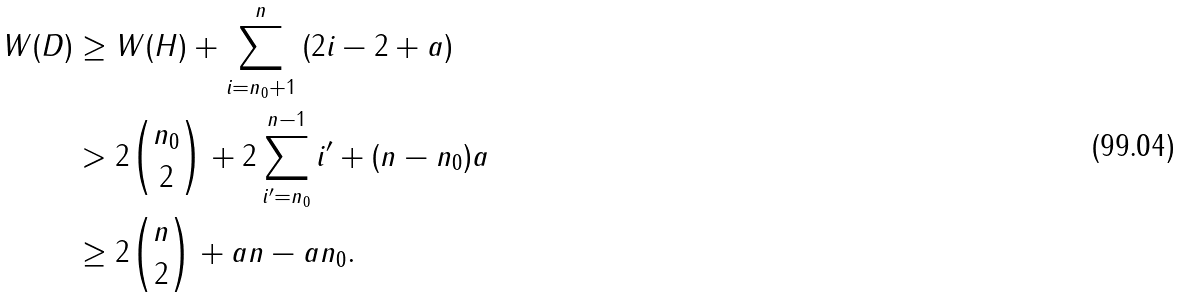Convert formula to latex. <formula><loc_0><loc_0><loc_500><loc_500>W ( D ) & \geq W ( H ) + \sum _ { i = n _ { 0 } + 1 } ^ { n } \left ( 2 i - 2 + a \right ) \\ & > 2 \binom { n _ { 0 } } { 2 } + 2 \sum _ { i ^ { \prime } = n _ { 0 } } ^ { n - 1 } i ^ { \prime } + ( n - n _ { 0 } ) a \\ & \geq 2 \binom { n } { 2 } + a n - a n _ { 0 } .</formula> 